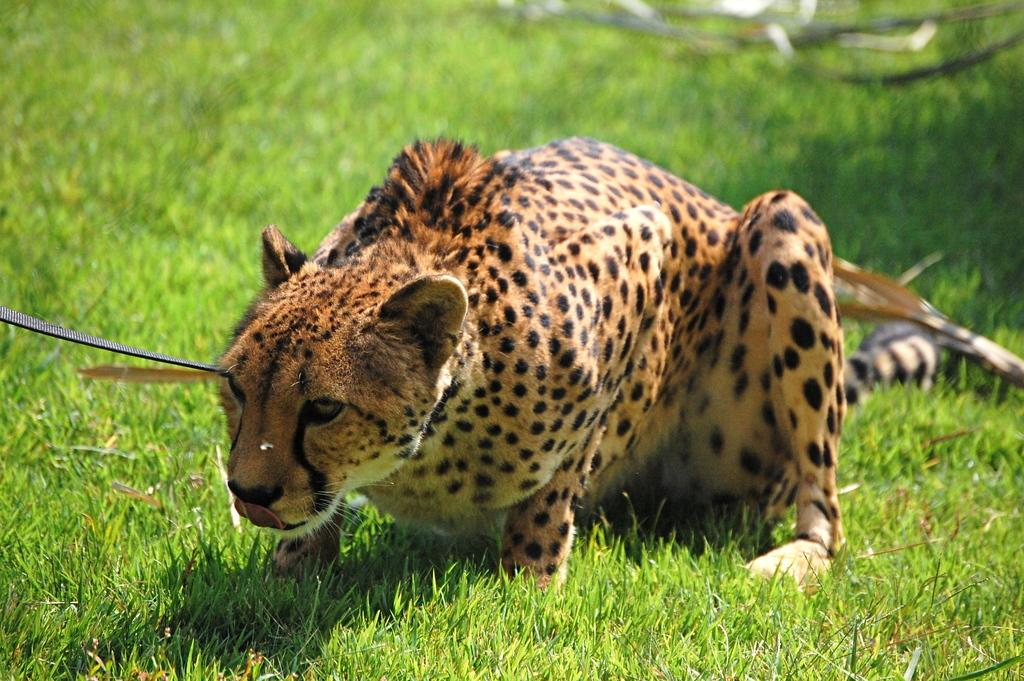What animal is in the image? There is a tiger in the image. Where is the tiger located? The tiger is on the ground. What type of surface is the tiger standing on? The ground has grass on it. Can you describe the background of the image? The background of the image is blurred. What type of can does the tiger use to drink water from the stream in the image? There is no can or stream present in the image; it features a tiger on the ground with grass. 